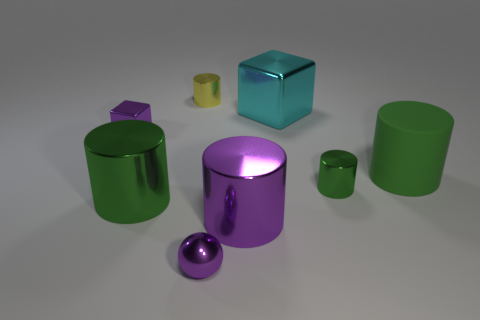What is the size of the metal cylinder that is the same color as the tiny shiny block?
Your answer should be compact. Large. There is a purple metal object that is to the left of the small purple thing on the right side of the green object on the left side of the yellow shiny cylinder; how big is it?
Give a very brief answer. Small. How many tiny yellow cylinders have the same material as the cyan block?
Offer a very short reply. 1. What number of yellow cylinders are the same size as the cyan object?
Your response must be concise. 0. There is a cylinder that is on the left side of the tiny cylinder that is to the left of the green metal object that is to the right of the cyan metallic cube; what is it made of?
Provide a short and direct response. Metal. How many things are either cyan matte spheres or purple metal things?
Provide a short and direct response. 3. Is there anything else that has the same material as the large cyan cube?
Your response must be concise. Yes. There is a large cyan metallic thing; what shape is it?
Keep it short and to the point. Cube. There is a metal thing on the left side of the green thing that is to the left of the sphere; what shape is it?
Give a very brief answer. Cube. Do the block in front of the large block and the large purple cylinder have the same material?
Your answer should be compact. Yes. 